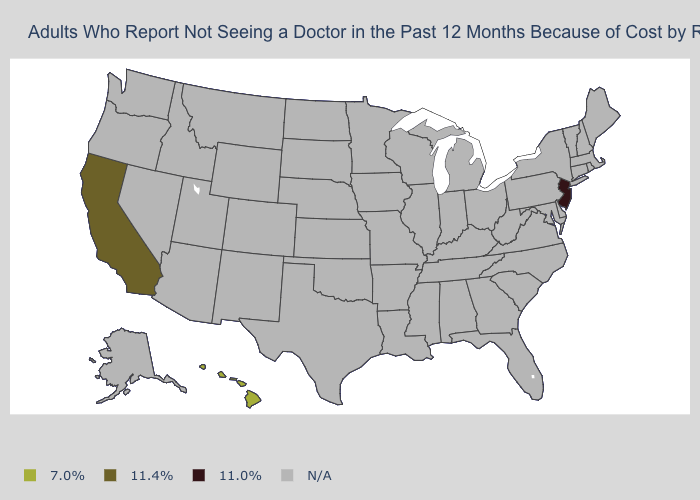Name the states that have a value in the range N/A?
Short answer required. Alabama, Alaska, Arizona, Arkansas, Colorado, Connecticut, Delaware, Florida, Georgia, Idaho, Illinois, Indiana, Iowa, Kansas, Kentucky, Louisiana, Maine, Maryland, Massachusetts, Michigan, Minnesota, Mississippi, Missouri, Montana, Nebraska, Nevada, New Hampshire, New Mexico, New York, North Carolina, North Dakota, Ohio, Oklahoma, Oregon, Pennsylvania, Rhode Island, South Carolina, South Dakota, Tennessee, Texas, Utah, Vermont, Virginia, Washington, West Virginia, Wisconsin, Wyoming. Which states have the highest value in the USA?
Concise answer only. Hawaii. What is the value of Colorado?
Short answer required. N/A. Which states have the lowest value in the West?
Quick response, please. California. What is the value of Utah?
Be succinct. N/A. What is the value of Illinois?
Answer briefly. N/A. What is the value of Virginia?
Keep it brief. N/A. What is the value of Ohio?
Quick response, please. N/A. What is the value of South Dakota?
Concise answer only. N/A. Name the states that have a value in the range N/A?
Concise answer only. Alabama, Alaska, Arizona, Arkansas, Colorado, Connecticut, Delaware, Florida, Georgia, Idaho, Illinois, Indiana, Iowa, Kansas, Kentucky, Louisiana, Maine, Maryland, Massachusetts, Michigan, Minnesota, Mississippi, Missouri, Montana, Nebraska, Nevada, New Hampshire, New Mexico, New York, North Carolina, North Dakota, Ohio, Oklahoma, Oregon, Pennsylvania, Rhode Island, South Carolina, South Dakota, Tennessee, Texas, Utah, Vermont, Virginia, Washington, West Virginia, Wisconsin, Wyoming. Does the map have missing data?
Quick response, please. Yes. Name the states that have a value in the range 11.0%?
Answer briefly. New Jersey. 